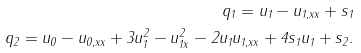Convert formula to latex. <formula><loc_0><loc_0><loc_500><loc_500>q _ { 1 } = u _ { 1 } - u _ { 1 , x x } + s _ { 1 } \\ q _ { 2 } = u _ { 0 } - u _ { 0 , x x } + 3 u _ { 1 } ^ { 2 } - u _ { 1 x } ^ { 2 } - 2 u _ { 1 } u _ { 1 , x x } + 4 s _ { 1 } u _ { 1 } + s _ { 2 } .</formula> 